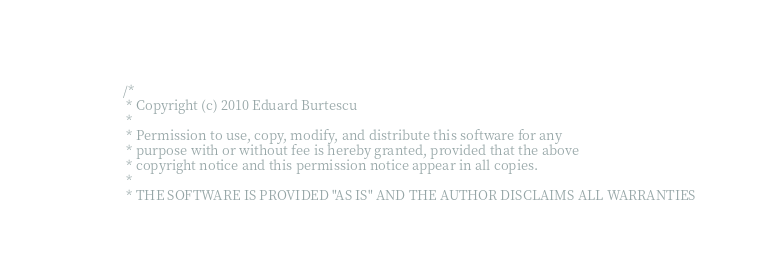<code> <loc_0><loc_0><loc_500><loc_500><_C++_>/*
 * Copyright (c) 2010 Eduard Burtescu
 *
 * Permission to use, copy, modify, and distribute this software for any
 * purpose with or without fee is hereby granted, provided that the above
 * copyright notice and this permission notice appear in all copies.
 *
 * THE SOFTWARE IS PROVIDED "AS IS" AND THE AUTHOR DISCLAIMS ALL WARRANTIES</code> 